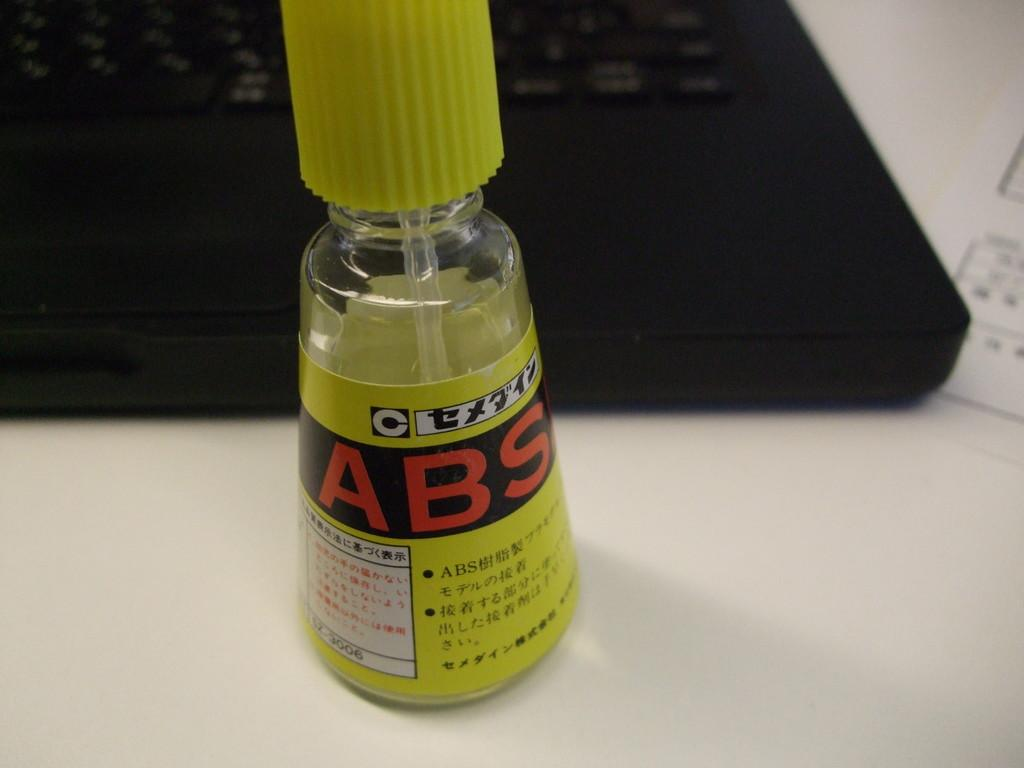<image>
Summarize the visual content of the image. A bottle of ABS is sitting on a table. 